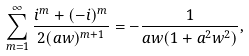Convert formula to latex. <formula><loc_0><loc_0><loc_500><loc_500>\sum _ { m = 1 } ^ { \infty } \frac { i ^ { m } + ( - i ) ^ { m } } { 2 ( a w ) ^ { m + 1 } } = - \frac { 1 } { a w ( 1 + a ^ { 2 } w ^ { 2 } ) } ,</formula> 